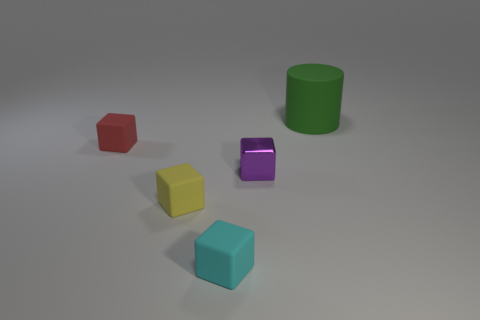Subtract all tiny shiny blocks. How many blocks are left? 3 Subtract 2 cubes. How many cubes are left? 2 Add 1 tiny gray metal cylinders. How many objects exist? 6 Subtract all cyan blocks. How many blocks are left? 3 Add 1 small yellow things. How many small yellow things exist? 2 Subtract 0 purple cylinders. How many objects are left? 5 Subtract all blocks. How many objects are left? 1 Subtract all green cubes. Subtract all blue balls. How many cubes are left? 4 Subtract all tiny brown rubber things. Subtract all small blocks. How many objects are left? 1 Add 5 yellow matte cubes. How many yellow matte cubes are left? 6 